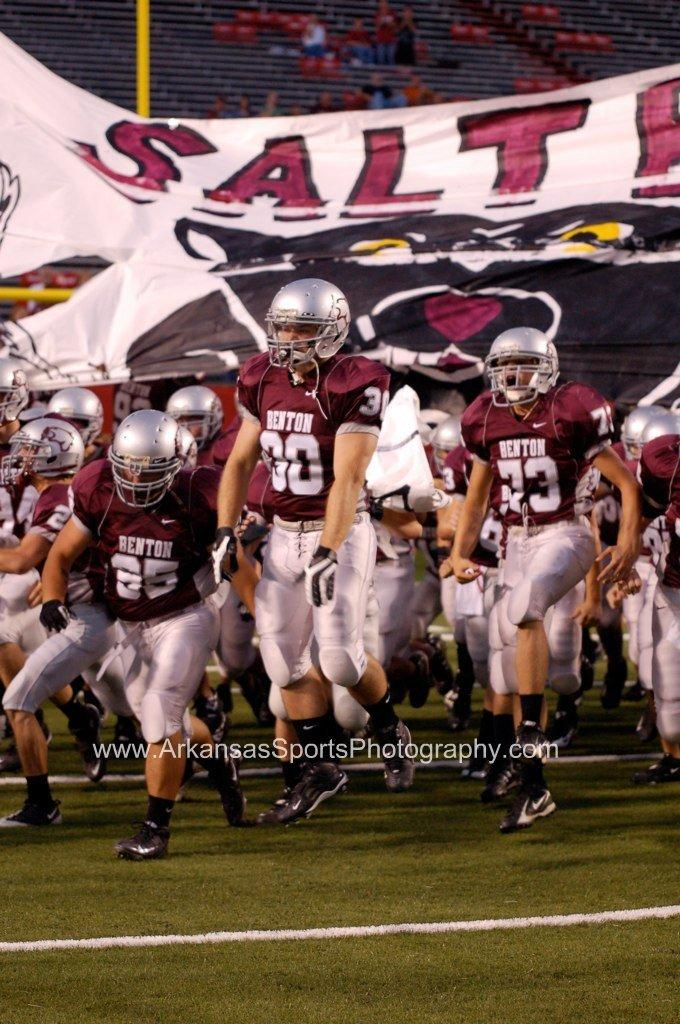What is the main subject of the image? There is a group of people standing in the center of the image. What can be seen in the background of the image? Chairs and a pole are visible in the background of the image. What is the surface on which the people are standing? The ground is visible at the bottom of the image. What time does the clock in the image show? There is no clock present in the image. What type of apparatus is being used by the people in the image? The image does not show any specific apparatus being used by the people. 